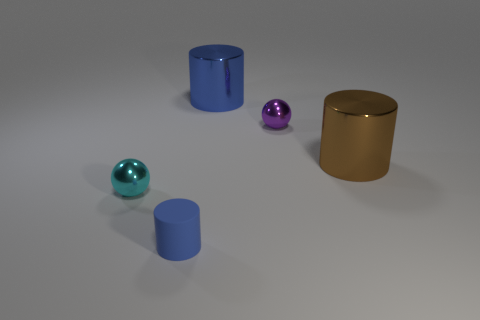Add 3 tiny purple balls. How many objects exist? 8 Subtract all cylinders. How many objects are left? 2 Subtract 0 yellow cylinders. How many objects are left? 5 Subtract all red objects. Subtract all cyan metal things. How many objects are left? 4 Add 1 small matte cylinders. How many small matte cylinders are left? 2 Add 1 matte objects. How many matte objects exist? 2 